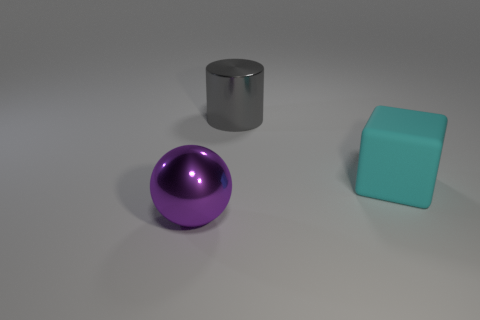Are there any other things that have the same material as the large cyan object?
Your response must be concise. No. What number of things are either brown metal cylinders or large matte cubes?
Offer a very short reply. 1. There is a object that is in front of the cylinder and left of the big cyan matte object; what shape is it?
Your answer should be compact. Sphere. Are there any big metal things in front of the cyan rubber block?
Ensure brevity in your answer.  Yes. How many cubes are either big objects or purple metal objects?
Your response must be concise. 1. Is the size of the gray object that is behind the matte block the same as the big cube?
Provide a short and direct response. Yes. What is the color of the block?
Give a very brief answer. Cyan. What color is the big shiny thing that is in front of the large cyan thing to the right of the big cylinder?
Give a very brief answer. Purple. Are there any objects made of the same material as the large cylinder?
Offer a terse response. Yes. The thing that is right of the big shiny object that is behind the big cyan matte cube is made of what material?
Your response must be concise. Rubber. 